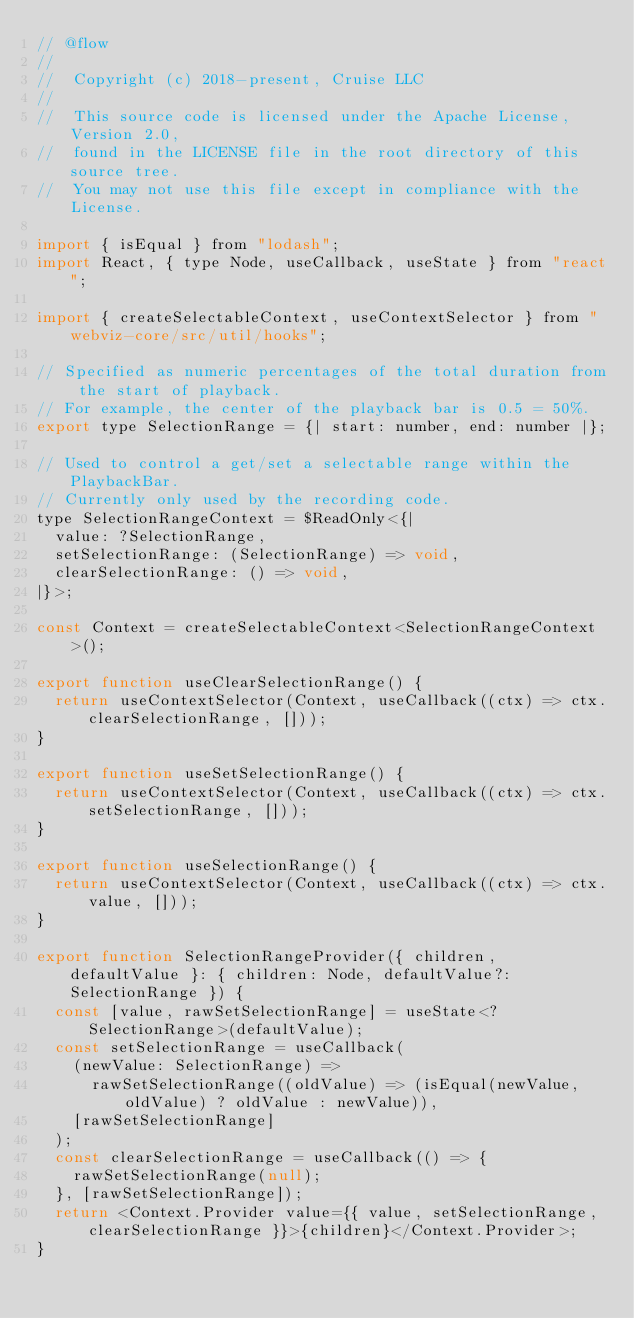Convert code to text. <code><loc_0><loc_0><loc_500><loc_500><_JavaScript_>// @flow
//
//  Copyright (c) 2018-present, Cruise LLC
//
//  This source code is licensed under the Apache License, Version 2.0,
//  found in the LICENSE file in the root directory of this source tree.
//  You may not use this file except in compliance with the License.

import { isEqual } from "lodash";
import React, { type Node, useCallback, useState } from "react";

import { createSelectableContext, useContextSelector } from "webviz-core/src/util/hooks";

// Specified as numeric percentages of the total duration from the start of playback.
// For example, the center of the playback bar is 0.5 = 50%.
export type SelectionRange = {| start: number, end: number |};

// Used to control a get/set a selectable range within the PlaybackBar.
// Currently only used by the recording code.
type SelectionRangeContext = $ReadOnly<{|
  value: ?SelectionRange,
  setSelectionRange: (SelectionRange) => void,
  clearSelectionRange: () => void,
|}>;

const Context = createSelectableContext<SelectionRangeContext>();

export function useClearSelectionRange() {
  return useContextSelector(Context, useCallback((ctx) => ctx.clearSelectionRange, []));
}

export function useSetSelectionRange() {
  return useContextSelector(Context, useCallback((ctx) => ctx.setSelectionRange, []));
}

export function useSelectionRange() {
  return useContextSelector(Context, useCallback((ctx) => ctx.value, []));
}

export function SelectionRangeProvider({ children, defaultValue }: { children: Node, defaultValue?: SelectionRange }) {
  const [value, rawSetSelectionRange] = useState<?SelectionRange>(defaultValue);
  const setSelectionRange = useCallback(
    (newValue: SelectionRange) =>
      rawSetSelectionRange((oldValue) => (isEqual(newValue, oldValue) ? oldValue : newValue)),
    [rawSetSelectionRange]
  );
  const clearSelectionRange = useCallback(() => {
    rawSetSelectionRange(null);
  }, [rawSetSelectionRange]);
  return <Context.Provider value={{ value, setSelectionRange, clearSelectionRange }}>{children}</Context.Provider>;
}
</code> 